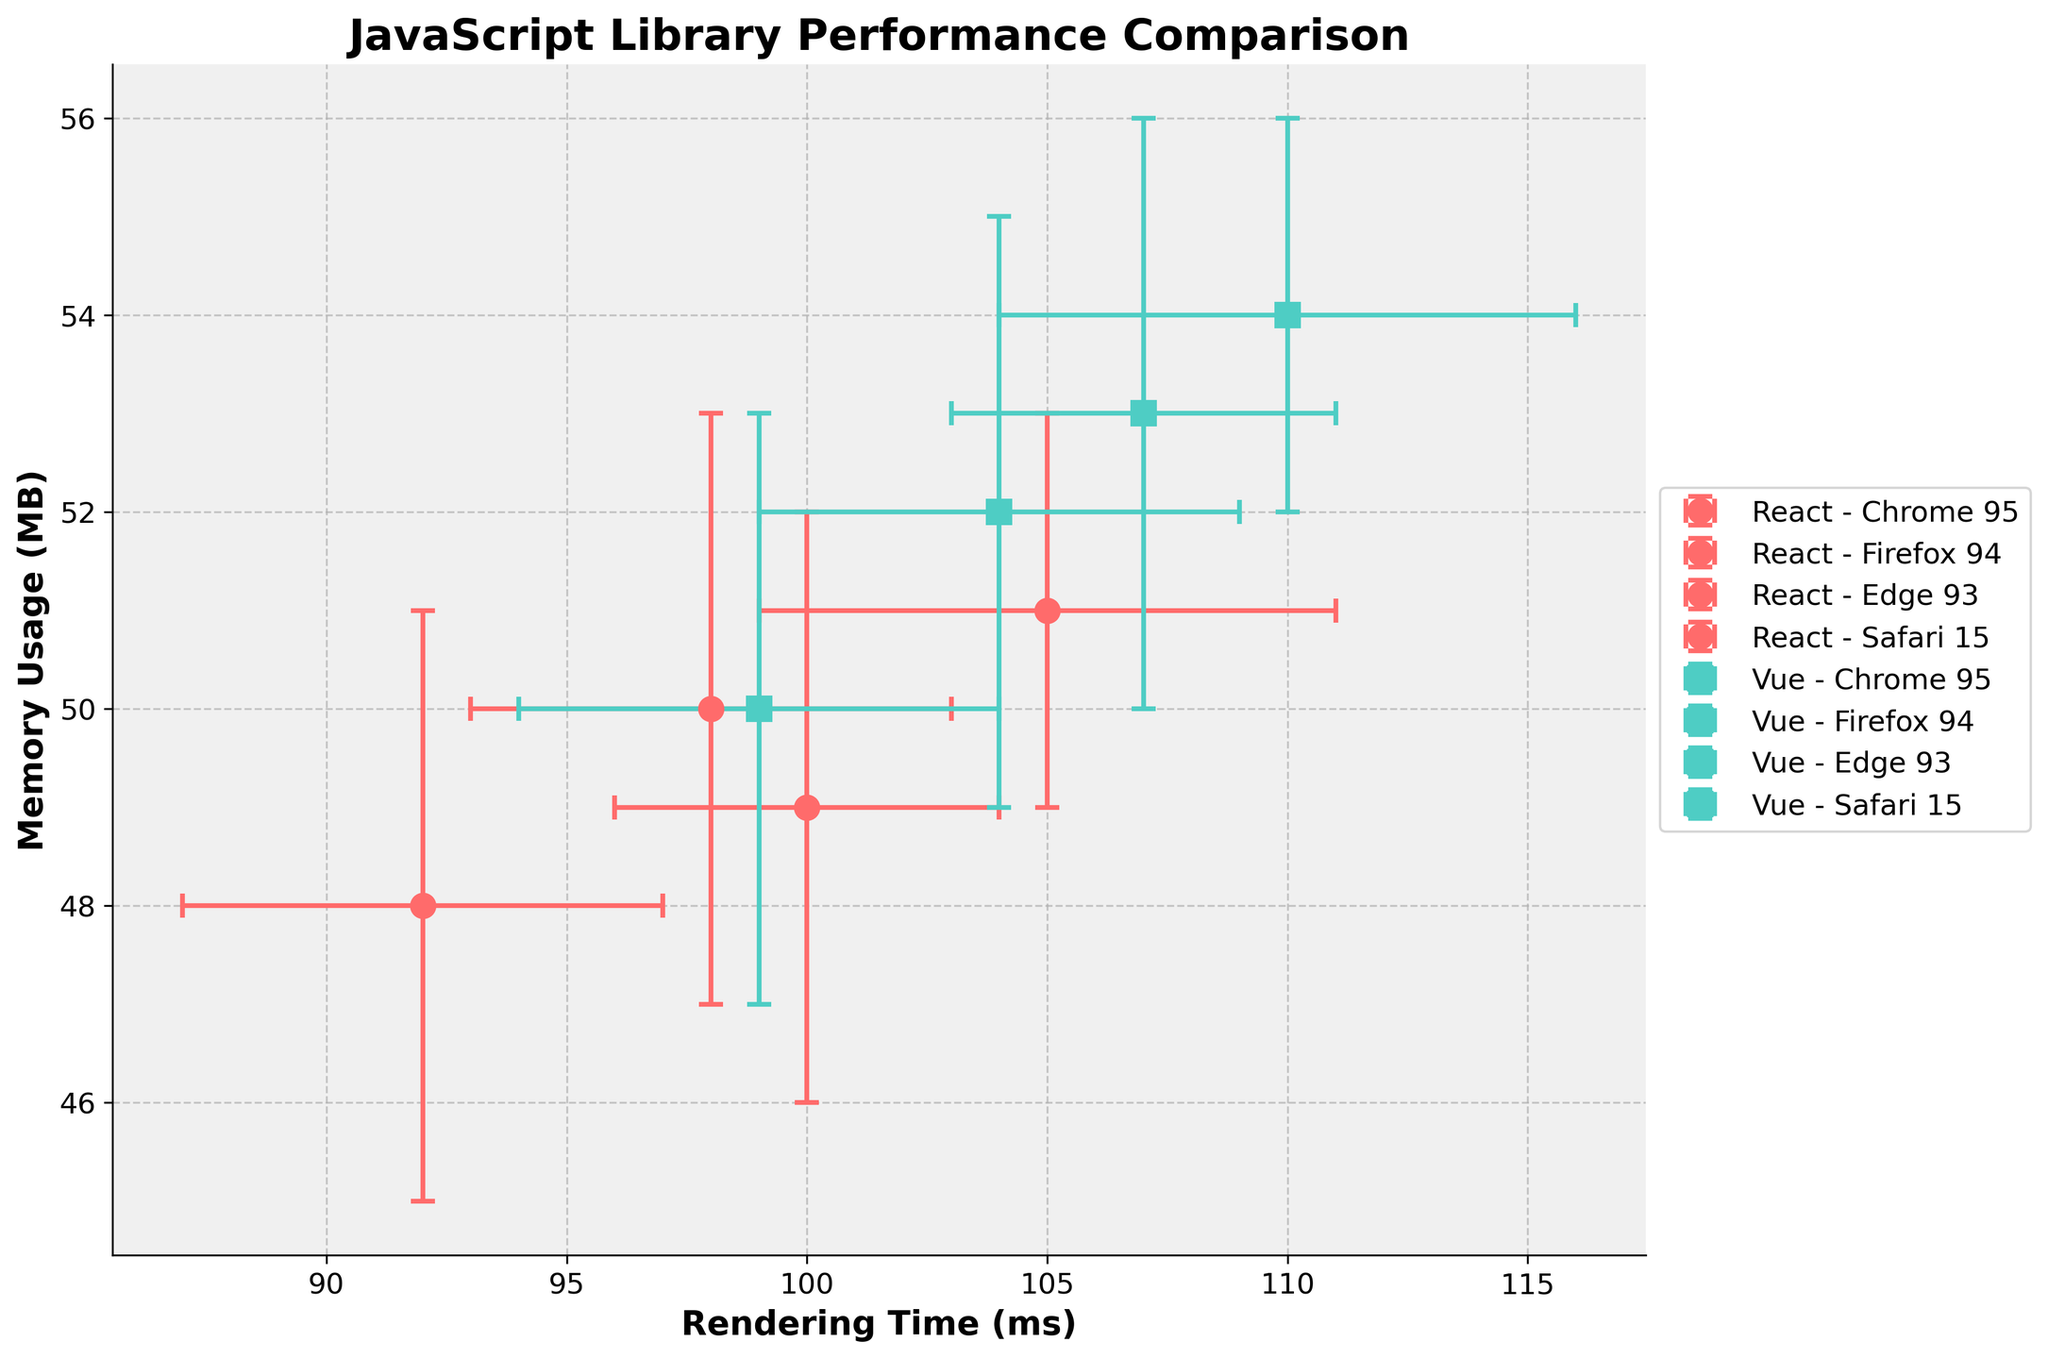What is the title of the figure? The title of the figure is displayed at the top center in bold, indicating the comparison of JavaScript libraries' performance regarding rendering time and memory usage. The title reads "JavaScript Library Performance Comparison".
Answer: JavaScript Library Performance Comparison How many different JavaScript libraries are compared in the figure? The figure includes markers and error bars for two distinct libraries, which can be identified by their distinct colors and markers in the legend. The libraries displayed are "React" and "Vue".
Answer: 2 Which library and browser combination has the lowest rendering time? By evaluating the x-axis values, the minimum rendering time is 92 ms, which corresponds to React on Safari 15 as seen from the marker position and corresponding legend.
Answer: React on Safari 15 Which browser shows the highest memory usage for the Vue library? Checking the y-axis values for the Vue library across different browsers, the highest memory usage is 54 MB, indicated by the combination of Vue on Firefox 94 in the figure.
Answer: Firefox 94 What is the approximate range of rendering time for both libraries across all browsers? The lowest rendering time is 92 ms (React on Safari 15), and the highest is 110 ms (Vue on Firefox 94). Therefore, the range is 110 ms - 92 ms.
Answer: 18 ms Which combination of browser and library shows the smallest error in rendering time? The smallest error in rendering time is 4 ms for React in Edge 93, as the error bars are shortest in size among the others that show 5 ms or 6 ms for rendering time errors.
Answer: React on Edge 93 Compare the memory usage error bars of React and Vue libraries. Which one tends to have more consistent memory usage across different browsers? React's memory usage error bars are generally smaller (mostly 3 MB) compared to Vue's error bars which are either 3 MB or 2 MB. Hence, React shows more consistent memory usage.
Answer: React What is the total difference in rendering time between the Vue and React libraries in Chrome 95? In Chrome 95, Vue has a rendering time of 104 ms, while React has 98 ms. The difference is calculated as 104 ms - 98 ms.
Answer: 6 ms Which browser and library combination has the overall lowest memory usage, and how much is it? The overall lowest memory usage is 48 MB observed for React on Safari 15 as per the data points on the y-axis.
Answer: React on Safari 15 